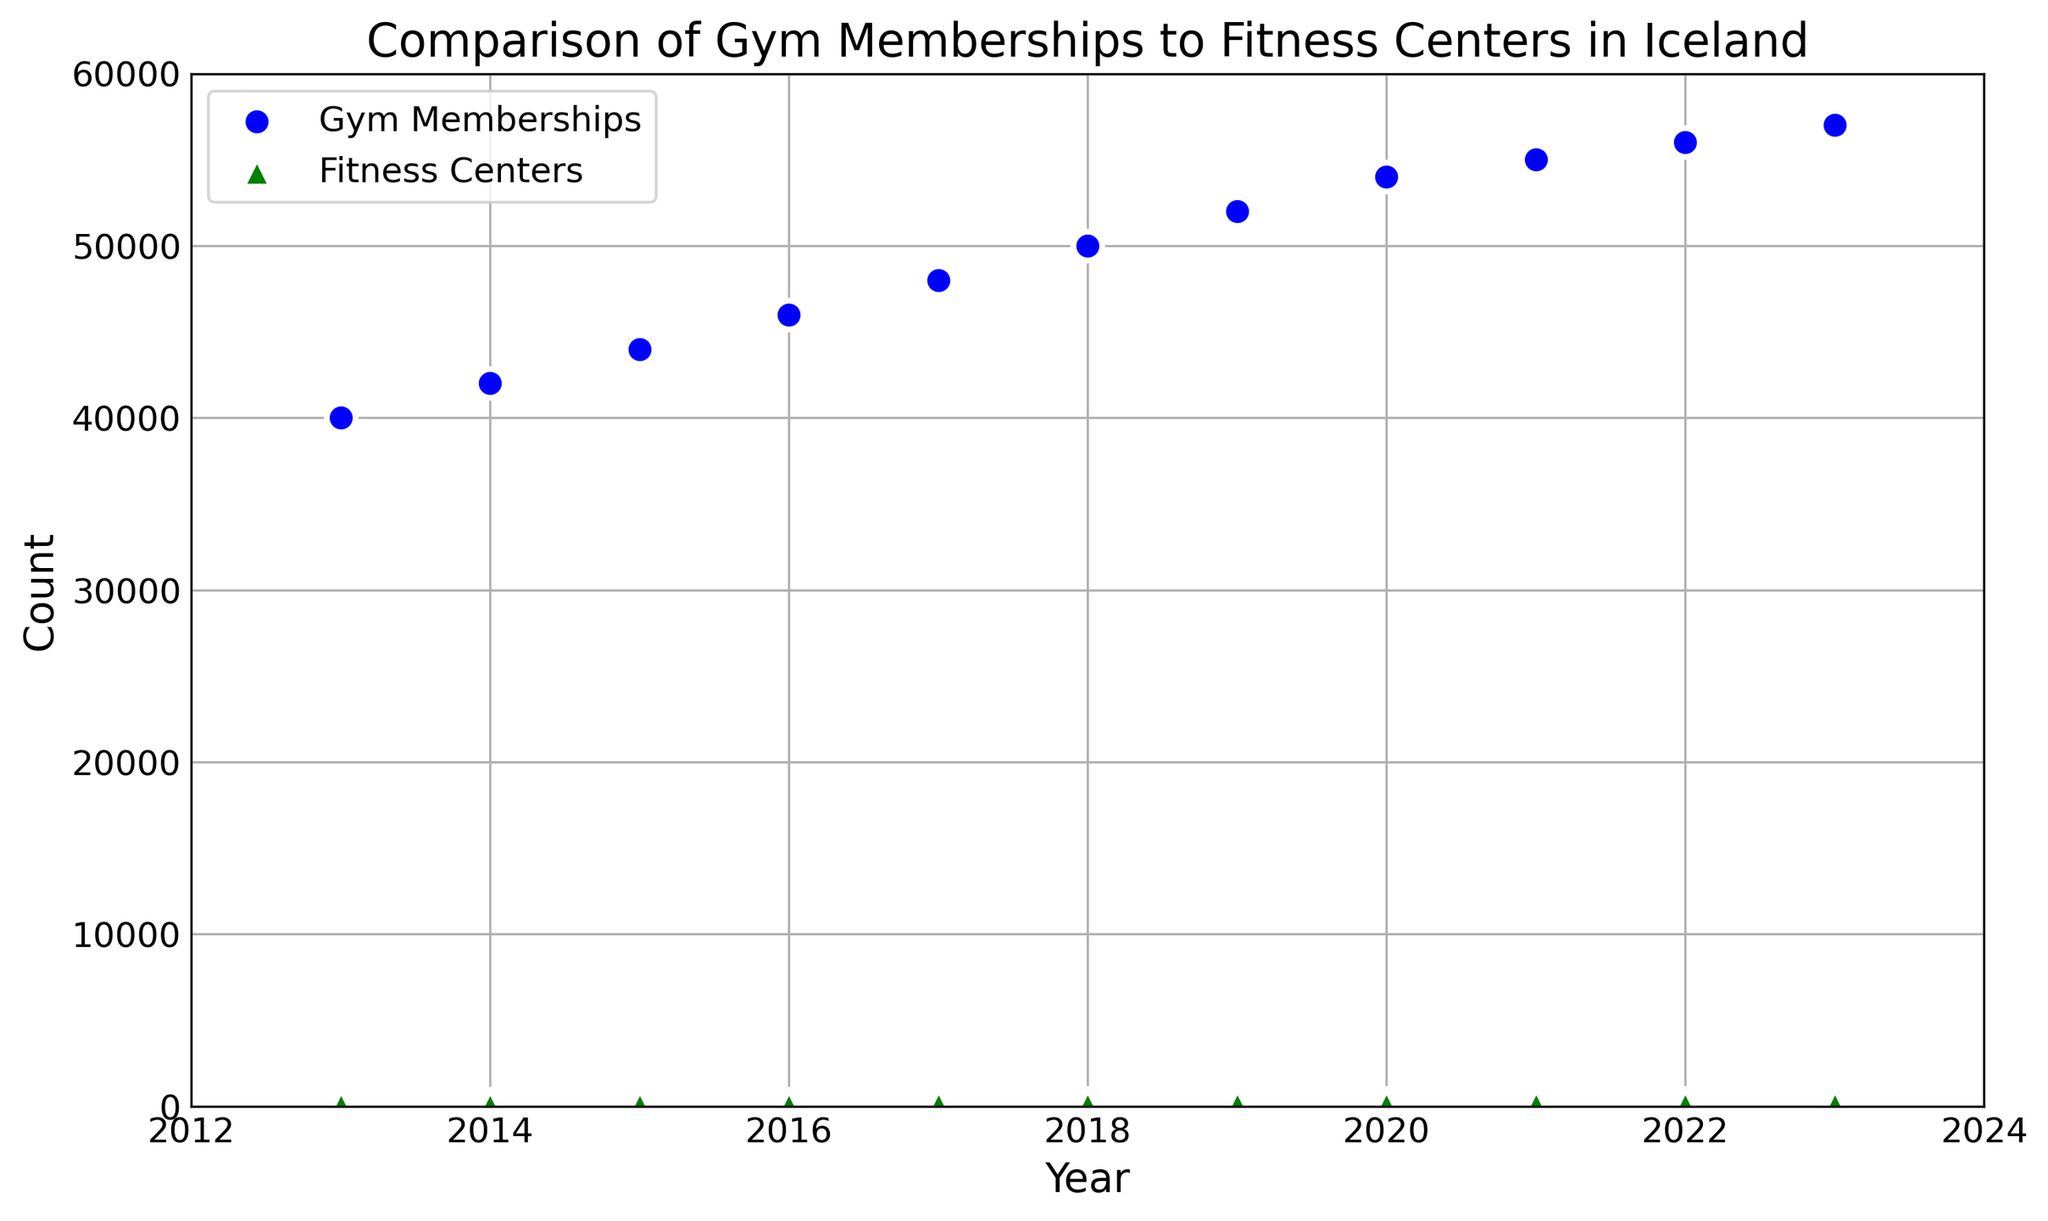What's the increase in gym memberships from 2013 to 2023? In 2013, the gym memberships were 40,000. In 2023, the gym memberships were 57,000. The increase is calculated by subtracting the 2013 value from the 2023 value: 57,000 - 40,000 = 17,000
Answer: 17,000 How many fitness centers were there in 2017 compared to 2023? In 2017, there were 172 fitness centers. In 2023, there were 200 fitness centers. To compare, we see that there are 28 more fitness centers in 2023 than in 2017 (200 - 172 = 28).
Answer: 28 more What’s the average number of gym memberships over the decade? The annual gym memberships over the decade are: 40,000, 42,000, 44,000, 46,000, 48,000, 50,000, 52,000, 54,000, 55,000, 56,000, 57,000. Adding them up gives 544,000. There are 11 years, so the average is 544,000 / 11, which is approximately 49,454.5
Answer: 49,454.5 Which year had a greater number of fitness centers, 2015 or 2019, and by how much? In 2015, there were 165 fitness centers. In 2019, there were 180 fitness centers. To find the difference: 180 - 165 = 15. Hence, 2019 had 15 more fitness centers than 2015.
Answer: 2019, by 15 Between which consecutive years was the largest increase in gym memberships observed? To find the largest increase, we need to compute the difference between consecutive years: 2014-2013: 2,000; 2015-2014: 2,000; 2016-2015: 2,000; 2017-2016: 2,000; 2018-2017: 2,000; 2019-2018: 2,000; 2020-2019: 2,000; 2021-2020: 1,000; 2022-2021: 1,000; 2023-2022: 1,000. The largest increase observed was 2,000 in multiple years.
Answer: 2014 to 2015, 2015 to 2016, 2016 to 2017, 2019 to 2020 What’s the overall trend in the number of fitness centers from 2013 to 2023? Observing the scatter plot, we can see that the number of fitness centers consistently increases each year from 150 in 2013 to 200 in 2023. This indicates an overall increasing trend.
Answer: Increasing How many more gym memberships were there in 2018 than in 2020? In 2018, there were 50,000 gym memberships and in 2020, there were 54,000 gym memberships. Subtracting these values gives 54,000 - 50,000 = 4,000.
Answer: 4,000 more How did the number of fitness centers change from 2021 to 2022? In 2021, there were 185 fitness centers, and in 2022 there were 190 fitness centers. The change is calculated as 190 - 185 = 5. So, there was an increase of 5 fitness centers.
Answer: Increased by 5 